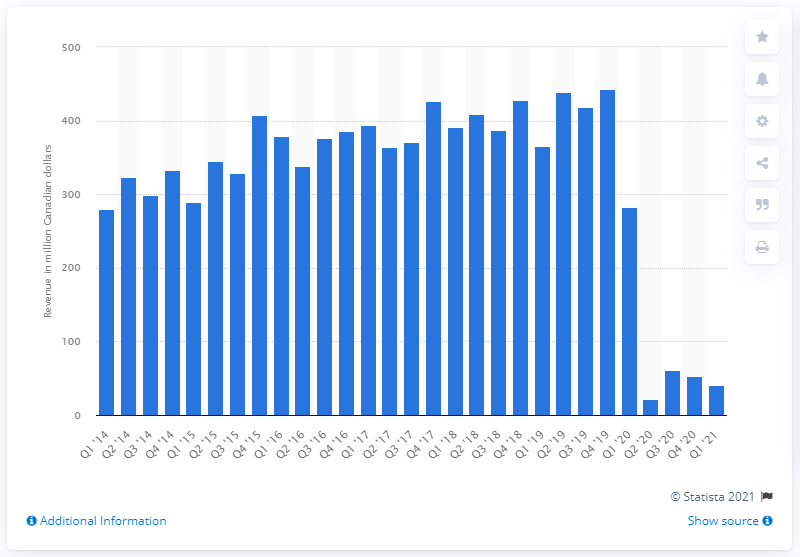Draw attention to some important aspects in this diagram. Cineplex's revenue for the first quarter of 2021 was $41.41 million. Cineplex generated $282.8 million in revenue during the corresponding fiscal period of 2020. 